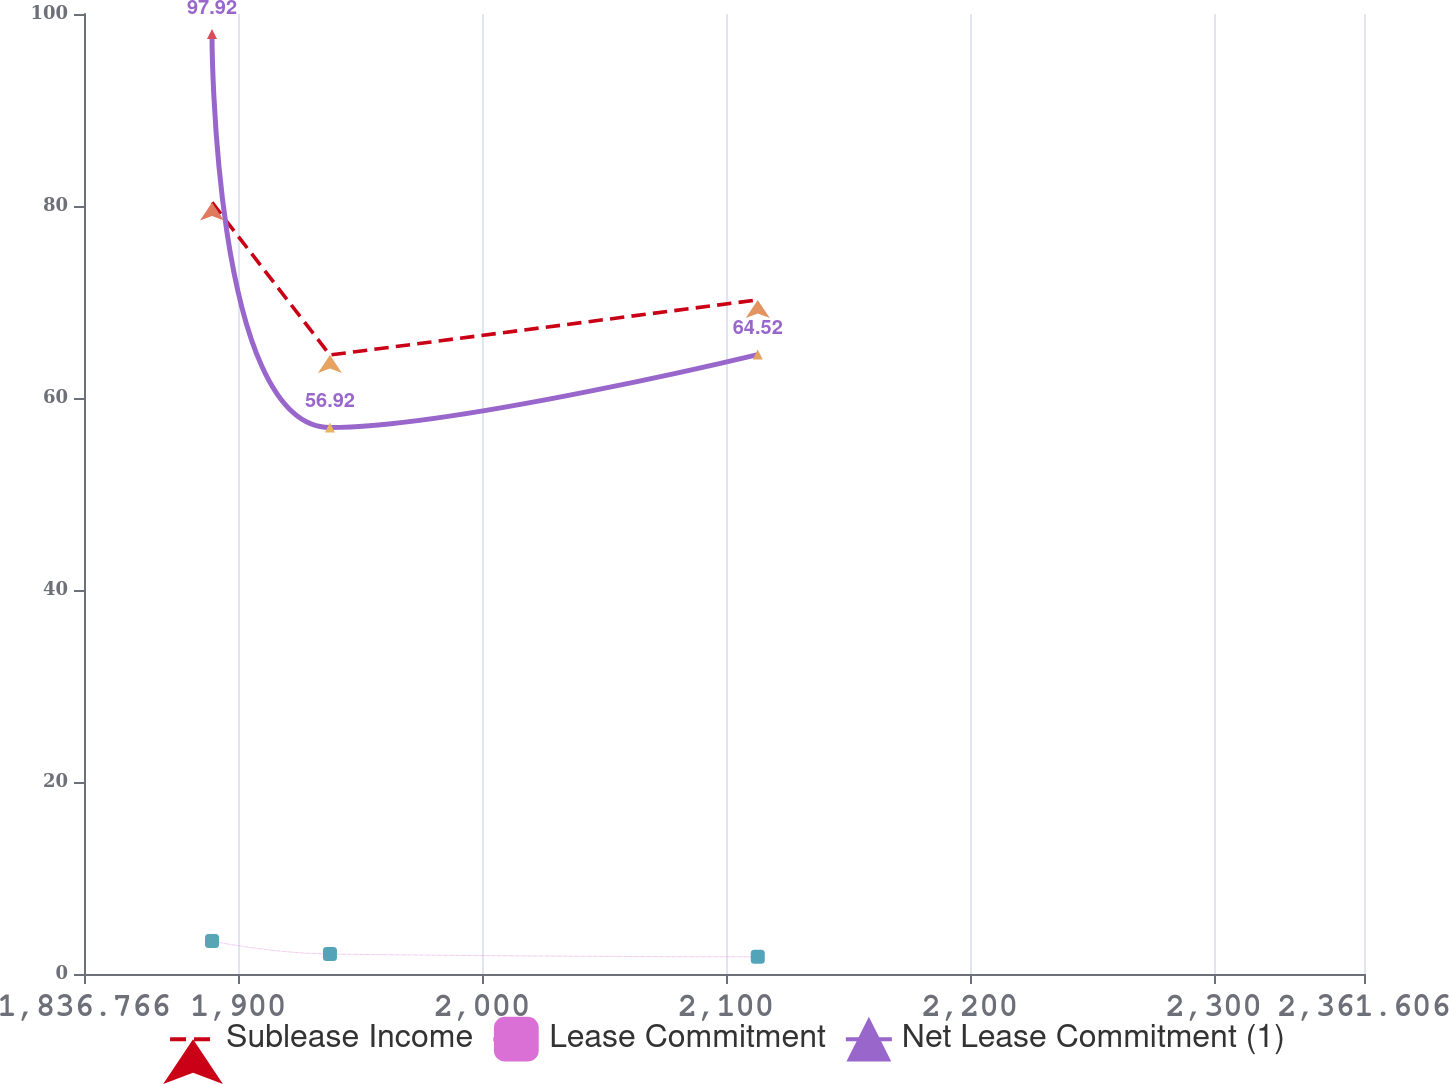<chart> <loc_0><loc_0><loc_500><loc_500><line_chart><ecel><fcel>Sublease Income<fcel>Lease Commitment<fcel>Net Lease Commitment (1)<nl><fcel>1889.25<fcel>80.37<fcel>3.43<fcel>97.92<nl><fcel>1937.61<fcel>64.48<fcel>2.08<fcel>56.92<nl><fcel>2113.03<fcel>70.22<fcel>1.79<fcel>64.52<nl><fcel>2365.73<fcel>60.29<fcel>1.27<fcel>45.62<nl><fcel>2414.09<fcel>38.47<fcel>1.03<fcel>28.26<nl></chart> 